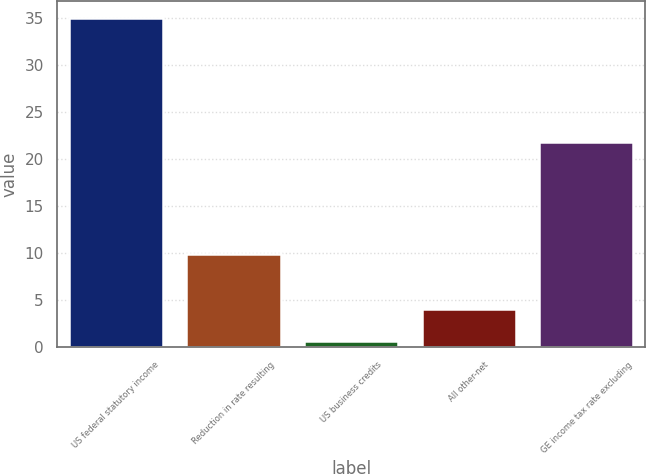Convert chart. <chart><loc_0><loc_0><loc_500><loc_500><bar_chart><fcel>US federal statutory income<fcel>Reduction in rate resulting<fcel>US business credits<fcel>All other-net<fcel>GE income tax rate excluding<nl><fcel>35<fcel>9.9<fcel>0.6<fcel>4.04<fcel>21.8<nl></chart> 